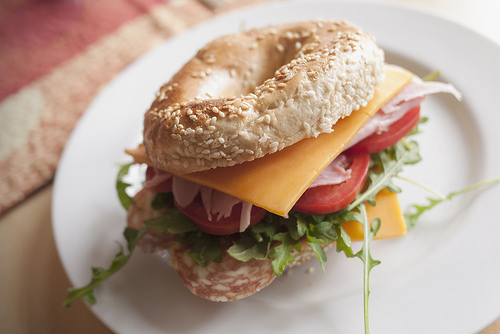<image>
Can you confirm if the lettuce is next to the bagel? No. The lettuce is not positioned next to the bagel. They are located in different areas of the scene. Where is the cheese in relation to the tomato? Is it under the tomato? No. The cheese is not positioned under the tomato. The vertical relationship between these objects is different. Is there a cheese on the sandwich? Yes. Looking at the image, I can see the cheese is positioned on top of the sandwich, with the sandwich providing support. 